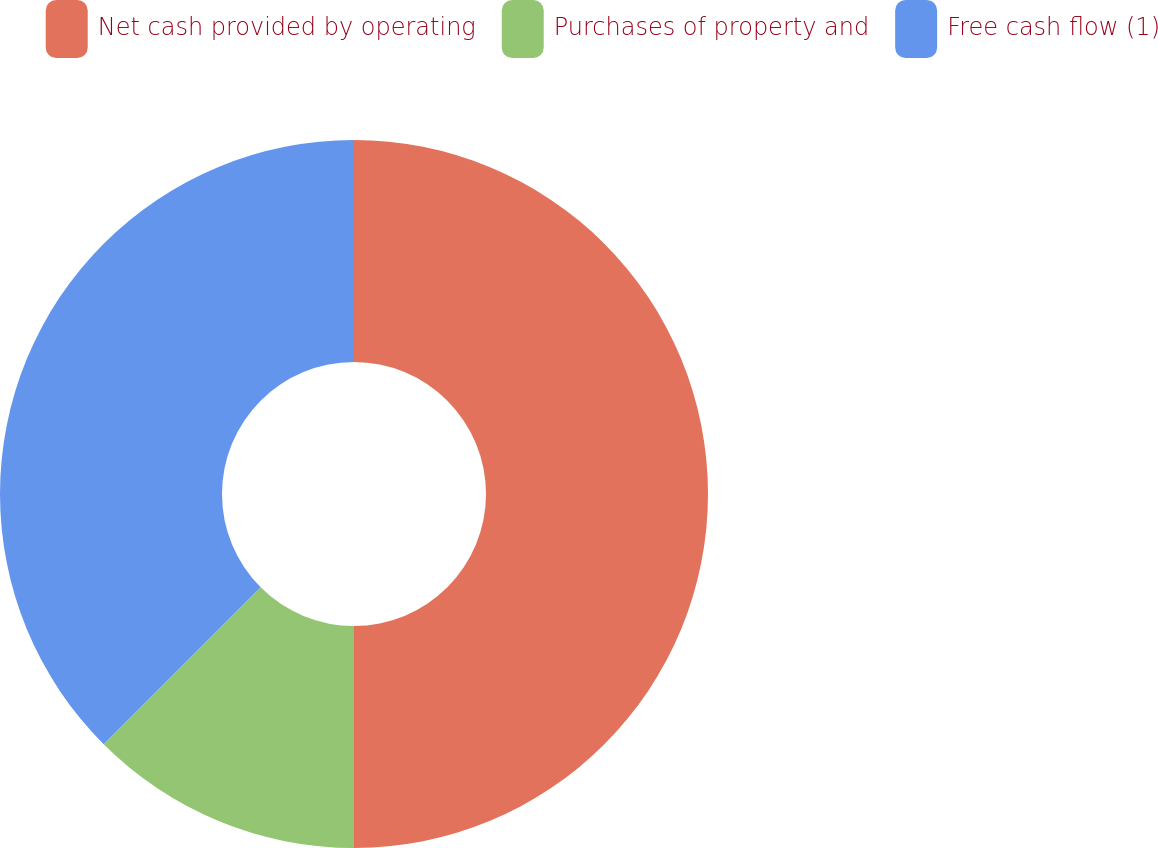<chart> <loc_0><loc_0><loc_500><loc_500><pie_chart><fcel>Net cash provided by operating<fcel>Purchases of property and<fcel>Free cash flow (1)<nl><fcel>50.0%<fcel>12.5%<fcel>37.5%<nl></chart> 